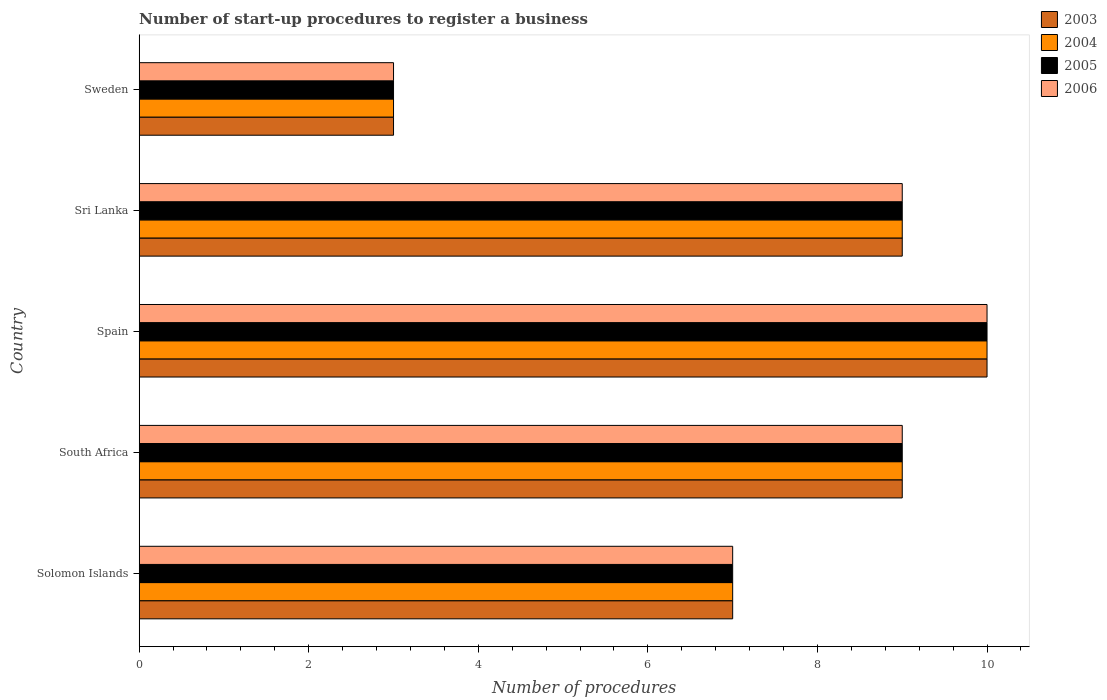How many different coloured bars are there?
Offer a terse response. 4. Are the number of bars per tick equal to the number of legend labels?
Your answer should be very brief. Yes. How many bars are there on the 2nd tick from the bottom?
Ensure brevity in your answer.  4. What is the label of the 1st group of bars from the top?
Ensure brevity in your answer.  Sweden. In how many cases, is the number of bars for a given country not equal to the number of legend labels?
Offer a terse response. 0. What is the number of procedures required to register a business in 2003 in Sri Lanka?
Offer a terse response. 9. Across all countries, what is the maximum number of procedures required to register a business in 2005?
Provide a short and direct response. 10. In which country was the number of procedures required to register a business in 2006 maximum?
Keep it short and to the point. Spain. In which country was the number of procedures required to register a business in 2005 minimum?
Provide a succinct answer. Sweden. What is the difference between the number of procedures required to register a business in 2003 in Spain and that in Sri Lanka?
Your answer should be compact. 1. What is the difference between the number of procedures required to register a business in 2006 in Sweden and the number of procedures required to register a business in 2003 in Sri Lanka?
Ensure brevity in your answer.  -6. What is the difference between the number of procedures required to register a business in 2005 and number of procedures required to register a business in 2003 in South Africa?
Keep it short and to the point. 0. In how many countries, is the number of procedures required to register a business in 2006 greater than 3.2 ?
Provide a short and direct response. 4. Is the number of procedures required to register a business in 2006 in South Africa less than that in Spain?
Your response must be concise. Yes. What is the difference between the highest and the lowest number of procedures required to register a business in 2006?
Ensure brevity in your answer.  7. In how many countries, is the number of procedures required to register a business in 2003 greater than the average number of procedures required to register a business in 2003 taken over all countries?
Offer a very short reply. 3. Is it the case that in every country, the sum of the number of procedures required to register a business in 2005 and number of procedures required to register a business in 2006 is greater than the sum of number of procedures required to register a business in 2004 and number of procedures required to register a business in 2003?
Offer a very short reply. No. What does the 1st bar from the bottom in Spain represents?
Give a very brief answer. 2003. Is it the case that in every country, the sum of the number of procedures required to register a business in 2006 and number of procedures required to register a business in 2003 is greater than the number of procedures required to register a business in 2004?
Give a very brief answer. Yes. How many bars are there?
Offer a very short reply. 20. What is the difference between two consecutive major ticks on the X-axis?
Give a very brief answer. 2. How are the legend labels stacked?
Ensure brevity in your answer.  Vertical. What is the title of the graph?
Give a very brief answer. Number of start-up procedures to register a business. What is the label or title of the X-axis?
Your response must be concise. Number of procedures. What is the Number of procedures in 2005 in Solomon Islands?
Offer a very short reply. 7. What is the Number of procedures of 2003 in South Africa?
Provide a succinct answer. 9. What is the Number of procedures in 2005 in South Africa?
Provide a succinct answer. 9. What is the Number of procedures of 2006 in South Africa?
Your answer should be compact. 9. What is the Number of procedures in 2004 in Sri Lanka?
Provide a succinct answer. 9. What is the Number of procedures of 2005 in Sri Lanka?
Offer a terse response. 9. What is the Number of procedures in 2004 in Sweden?
Make the answer very short. 3. Across all countries, what is the maximum Number of procedures of 2003?
Your answer should be compact. 10. Across all countries, what is the maximum Number of procedures in 2005?
Give a very brief answer. 10. Across all countries, what is the minimum Number of procedures of 2003?
Give a very brief answer. 3. Across all countries, what is the minimum Number of procedures in 2004?
Provide a succinct answer. 3. Across all countries, what is the minimum Number of procedures of 2006?
Offer a terse response. 3. What is the difference between the Number of procedures in 2003 in Solomon Islands and that in South Africa?
Give a very brief answer. -2. What is the difference between the Number of procedures in 2005 in Solomon Islands and that in South Africa?
Make the answer very short. -2. What is the difference between the Number of procedures of 2003 in Solomon Islands and that in Spain?
Provide a short and direct response. -3. What is the difference between the Number of procedures of 2004 in Solomon Islands and that in Spain?
Offer a terse response. -3. What is the difference between the Number of procedures in 2005 in Solomon Islands and that in Spain?
Your answer should be compact. -3. What is the difference between the Number of procedures of 2003 in Solomon Islands and that in Sri Lanka?
Ensure brevity in your answer.  -2. What is the difference between the Number of procedures in 2003 in Solomon Islands and that in Sweden?
Provide a short and direct response. 4. What is the difference between the Number of procedures in 2006 in Solomon Islands and that in Sweden?
Your answer should be compact. 4. What is the difference between the Number of procedures of 2003 in South Africa and that in Spain?
Provide a succinct answer. -1. What is the difference between the Number of procedures of 2004 in South Africa and that in Spain?
Provide a succinct answer. -1. What is the difference between the Number of procedures in 2005 in South Africa and that in Spain?
Provide a short and direct response. -1. What is the difference between the Number of procedures in 2006 in South Africa and that in Spain?
Make the answer very short. -1. What is the difference between the Number of procedures of 2003 in South Africa and that in Sri Lanka?
Your response must be concise. 0. What is the difference between the Number of procedures of 2005 in South Africa and that in Sri Lanka?
Give a very brief answer. 0. What is the difference between the Number of procedures in 2003 in South Africa and that in Sweden?
Make the answer very short. 6. What is the difference between the Number of procedures of 2005 in South Africa and that in Sweden?
Your answer should be compact. 6. What is the difference between the Number of procedures in 2006 in Spain and that in Sri Lanka?
Make the answer very short. 1. What is the difference between the Number of procedures of 2003 in Spain and that in Sweden?
Keep it short and to the point. 7. What is the difference between the Number of procedures of 2006 in Spain and that in Sweden?
Ensure brevity in your answer.  7. What is the difference between the Number of procedures of 2003 in Sri Lanka and that in Sweden?
Your answer should be compact. 6. What is the difference between the Number of procedures of 2004 in Sri Lanka and that in Sweden?
Your response must be concise. 6. What is the difference between the Number of procedures in 2003 in Solomon Islands and the Number of procedures in 2006 in South Africa?
Your answer should be very brief. -2. What is the difference between the Number of procedures of 2003 in Solomon Islands and the Number of procedures of 2004 in Spain?
Provide a short and direct response. -3. What is the difference between the Number of procedures in 2003 in Solomon Islands and the Number of procedures in 2005 in Spain?
Keep it short and to the point. -3. What is the difference between the Number of procedures of 2003 in Solomon Islands and the Number of procedures of 2006 in Spain?
Ensure brevity in your answer.  -3. What is the difference between the Number of procedures in 2004 in Solomon Islands and the Number of procedures in 2005 in Spain?
Provide a succinct answer. -3. What is the difference between the Number of procedures of 2004 in Solomon Islands and the Number of procedures of 2006 in Spain?
Your answer should be compact. -3. What is the difference between the Number of procedures in 2005 in Solomon Islands and the Number of procedures in 2006 in Spain?
Make the answer very short. -3. What is the difference between the Number of procedures of 2004 in Solomon Islands and the Number of procedures of 2006 in Sri Lanka?
Your answer should be compact. -2. What is the difference between the Number of procedures of 2005 in Solomon Islands and the Number of procedures of 2006 in Sri Lanka?
Provide a succinct answer. -2. What is the difference between the Number of procedures of 2003 in Solomon Islands and the Number of procedures of 2004 in Sweden?
Keep it short and to the point. 4. What is the difference between the Number of procedures of 2003 in Solomon Islands and the Number of procedures of 2005 in Sweden?
Your answer should be compact. 4. What is the difference between the Number of procedures in 2004 in Solomon Islands and the Number of procedures in 2006 in Sweden?
Provide a succinct answer. 4. What is the difference between the Number of procedures of 2003 in South Africa and the Number of procedures of 2005 in Spain?
Provide a short and direct response. -1. What is the difference between the Number of procedures of 2004 in South Africa and the Number of procedures of 2005 in Spain?
Keep it short and to the point. -1. What is the difference between the Number of procedures of 2004 in South Africa and the Number of procedures of 2006 in Spain?
Ensure brevity in your answer.  -1. What is the difference between the Number of procedures of 2003 in South Africa and the Number of procedures of 2006 in Sri Lanka?
Provide a short and direct response. 0. What is the difference between the Number of procedures of 2004 in South Africa and the Number of procedures of 2005 in Sri Lanka?
Your response must be concise. 0. What is the difference between the Number of procedures of 2004 in South Africa and the Number of procedures of 2006 in Sri Lanka?
Ensure brevity in your answer.  0. What is the difference between the Number of procedures in 2003 in South Africa and the Number of procedures in 2005 in Sweden?
Your answer should be compact. 6. What is the difference between the Number of procedures of 2004 in South Africa and the Number of procedures of 2005 in Sweden?
Ensure brevity in your answer.  6. What is the difference between the Number of procedures of 2004 in South Africa and the Number of procedures of 2006 in Sweden?
Provide a short and direct response. 6. What is the difference between the Number of procedures of 2005 in South Africa and the Number of procedures of 2006 in Sweden?
Your response must be concise. 6. What is the difference between the Number of procedures of 2004 in Spain and the Number of procedures of 2005 in Sri Lanka?
Offer a very short reply. 1. What is the difference between the Number of procedures in 2004 in Spain and the Number of procedures in 2006 in Sri Lanka?
Your response must be concise. 1. What is the difference between the Number of procedures of 2003 in Spain and the Number of procedures of 2004 in Sweden?
Offer a terse response. 7. What is the difference between the Number of procedures in 2003 in Spain and the Number of procedures in 2005 in Sweden?
Make the answer very short. 7. What is the difference between the Number of procedures in 2004 in Spain and the Number of procedures in 2005 in Sweden?
Offer a very short reply. 7. What is the difference between the Number of procedures in 2004 in Spain and the Number of procedures in 2006 in Sweden?
Provide a short and direct response. 7. What is the difference between the Number of procedures of 2005 in Spain and the Number of procedures of 2006 in Sweden?
Ensure brevity in your answer.  7. What is the difference between the Number of procedures of 2003 in Sri Lanka and the Number of procedures of 2004 in Sweden?
Provide a succinct answer. 6. What is the average Number of procedures of 2003 per country?
Your response must be concise. 7.6. What is the average Number of procedures of 2005 per country?
Your answer should be very brief. 7.6. What is the average Number of procedures of 2006 per country?
Your response must be concise. 7.6. What is the difference between the Number of procedures in 2003 and Number of procedures in 2004 in Solomon Islands?
Your answer should be very brief. 0. What is the difference between the Number of procedures in 2003 and Number of procedures in 2006 in Solomon Islands?
Your answer should be compact. 0. What is the difference between the Number of procedures of 2005 and Number of procedures of 2006 in Solomon Islands?
Your response must be concise. 0. What is the difference between the Number of procedures in 2003 and Number of procedures in 2004 in South Africa?
Your response must be concise. 0. What is the difference between the Number of procedures in 2004 and Number of procedures in 2006 in South Africa?
Your answer should be very brief. 0. What is the difference between the Number of procedures of 2005 and Number of procedures of 2006 in South Africa?
Your answer should be compact. 0. What is the difference between the Number of procedures in 2003 and Number of procedures in 2006 in Spain?
Offer a very short reply. 0. What is the difference between the Number of procedures of 2004 and Number of procedures of 2005 in Spain?
Provide a succinct answer. 0. What is the difference between the Number of procedures in 2004 and Number of procedures in 2006 in Spain?
Your response must be concise. 0. What is the difference between the Number of procedures in 2005 and Number of procedures in 2006 in Spain?
Keep it short and to the point. 0. What is the difference between the Number of procedures in 2003 and Number of procedures in 2005 in Sri Lanka?
Your response must be concise. 0. What is the difference between the Number of procedures of 2005 and Number of procedures of 2006 in Sri Lanka?
Your response must be concise. 0. What is the difference between the Number of procedures of 2003 and Number of procedures of 2005 in Sweden?
Offer a terse response. 0. What is the difference between the Number of procedures of 2003 and Number of procedures of 2006 in Sweden?
Make the answer very short. 0. What is the difference between the Number of procedures in 2004 and Number of procedures in 2005 in Sweden?
Ensure brevity in your answer.  0. What is the difference between the Number of procedures in 2004 and Number of procedures in 2006 in Sweden?
Offer a very short reply. 0. What is the ratio of the Number of procedures of 2004 in Solomon Islands to that in South Africa?
Your answer should be compact. 0.78. What is the ratio of the Number of procedures of 2005 in Solomon Islands to that in South Africa?
Keep it short and to the point. 0.78. What is the ratio of the Number of procedures of 2003 in Solomon Islands to that in Spain?
Offer a terse response. 0.7. What is the ratio of the Number of procedures in 2005 in Solomon Islands to that in Spain?
Make the answer very short. 0.7. What is the ratio of the Number of procedures in 2006 in Solomon Islands to that in Spain?
Offer a very short reply. 0.7. What is the ratio of the Number of procedures of 2004 in Solomon Islands to that in Sri Lanka?
Your response must be concise. 0.78. What is the ratio of the Number of procedures of 2005 in Solomon Islands to that in Sri Lanka?
Your answer should be compact. 0.78. What is the ratio of the Number of procedures of 2003 in Solomon Islands to that in Sweden?
Provide a succinct answer. 2.33. What is the ratio of the Number of procedures in 2004 in Solomon Islands to that in Sweden?
Provide a succinct answer. 2.33. What is the ratio of the Number of procedures of 2005 in Solomon Islands to that in Sweden?
Provide a short and direct response. 2.33. What is the ratio of the Number of procedures of 2006 in Solomon Islands to that in Sweden?
Your response must be concise. 2.33. What is the ratio of the Number of procedures of 2006 in South Africa to that in Spain?
Your response must be concise. 0.9. What is the ratio of the Number of procedures of 2003 in South Africa to that in Sri Lanka?
Your response must be concise. 1. What is the ratio of the Number of procedures in 2004 in South Africa to that in Sri Lanka?
Ensure brevity in your answer.  1. What is the ratio of the Number of procedures in 2006 in South Africa to that in Sri Lanka?
Give a very brief answer. 1. What is the ratio of the Number of procedures of 2004 in South Africa to that in Sweden?
Provide a succinct answer. 3. What is the ratio of the Number of procedures of 2006 in Spain to that in Sri Lanka?
Offer a terse response. 1.11. What is the ratio of the Number of procedures of 2003 in Spain to that in Sweden?
Offer a very short reply. 3.33. What is the ratio of the Number of procedures of 2005 in Spain to that in Sweden?
Offer a very short reply. 3.33. What is the ratio of the Number of procedures of 2003 in Sri Lanka to that in Sweden?
Make the answer very short. 3. What is the ratio of the Number of procedures in 2004 in Sri Lanka to that in Sweden?
Keep it short and to the point. 3. What is the ratio of the Number of procedures in 2005 in Sri Lanka to that in Sweden?
Provide a succinct answer. 3. What is the ratio of the Number of procedures in 2006 in Sri Lanka to that in Sweden?
Your answer should be very brief. 3. What is the difference between the highest and the second highest Number of procedures of 2006?
Your answer should be very brief. 1. What is the difference between the highest and the lowest Number of procedures in 2004?
Your answer should be very brief. 7. What is the difference between the highest and the lowest Number of procedures of 2005?
Offer a terse response. 7. What is the difference between the highest and the lowest Number of procedures of 2006?
Ensure brevity in your answer.  7. 